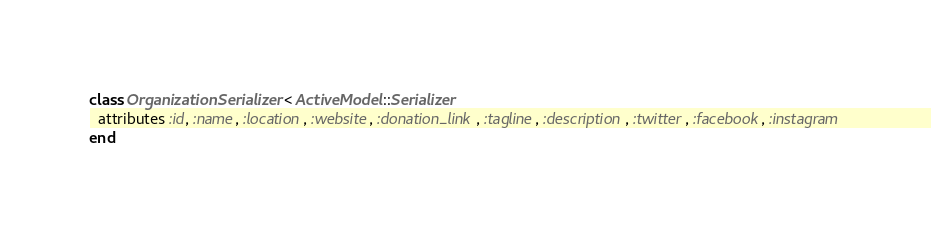Convert code to text. <code><loc_0><loc_0><loc_500><loc_500><_Ruby_>class OrganizationSerializer < ActiveModel::Serializer
  attributes :id, :name, :location, :website, :donation_link, :tagline, :description, :twitter, :facebook, :instagram
end
</code> 